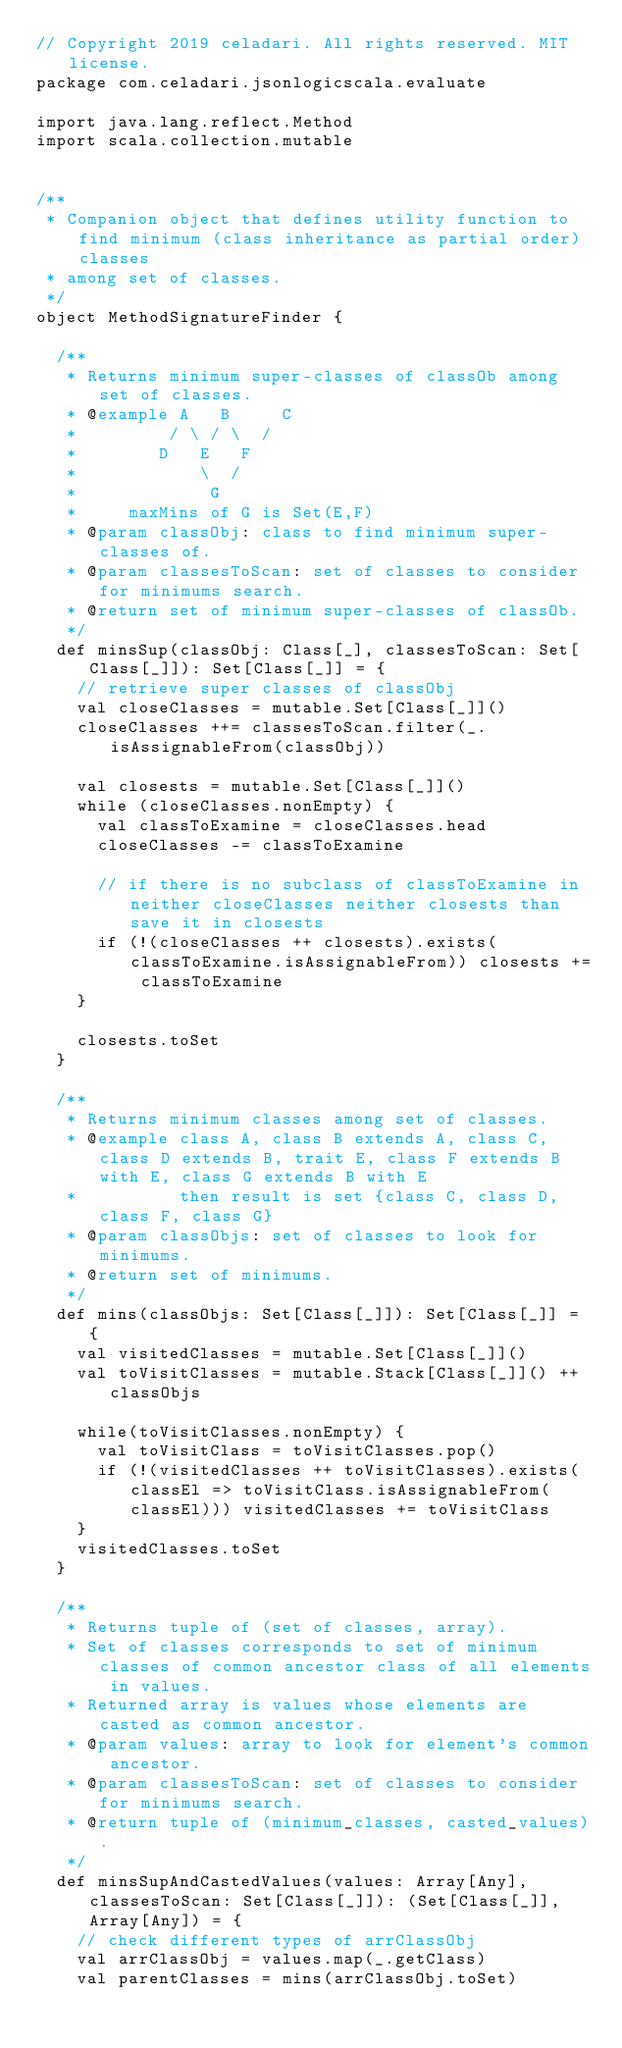<code> <loc_0><loc_0><loc_500><loc_500><_Scala_>// Copyright 2019 celadari. All rights reserved. MIT license.
package com.celadari.jsonlogicscala.evaluate

import java.lang.reflect.Method
import scala.collection.mutable


/**
 * Companion object that defines utility function to find minimum (class inheritance as partial order) classes
 * among set of classes.
 */
object MethodSignatureFinder {

  /**
   * Returns minimum super-classes of classOb among set of classes.
   * @example A   B     C
   *         / \ / \  /
   *        D   E   F
   *            \  /
   *             G
   *     maxMins of G is Set(E,F)
   * @param classObj: class to find minimum super-classes of.
   * @param classesToScan: set of classes to consider for minimums search.
   * @return set of minimum super-classes of classOb.
   */
  def minsSup(classObj: Class[_], classesToScan: Set[Class[_]]): Set[Class[_]] = {
    // retrieve super classes of classObj
    val closeClasses = mutable.Set[Class[_]]()
    closeClasses ++= classesToScan.filter(_.isAssignableFrom(classObj))

    val closests = mutable.Set[Class[_]]()
    while (closeClasses.nonEmpty) {
      val classToExamine = closeClasses.head
      closeClasses -= classToExamine

      // if there is no subclass of classToExamine in neither closeClasses neither closests than save it in closests
      if (!(closeClasses ++ closests).exists(classToExamine.isAssignableFrom)) closests += classToExamine
    }

    closests.toSet
  }

  /**
   * Returns minimum classes among set of classes.
   * @example class A, class B extends A, class C, class D extends B, trait E, class F extends B with E, class G extends B with E
   *          then result is set {class C, class D, class F, class G}
   * @param classObjs: set of classes to look for minimums.
   * @return set of minimums.
   */
  def mins(classObjs: Set[Class[_]]): Set[Class[_]] = {
    val visitedClasses = mutable.Set[Class[_]]()
    val toVisitClasses = mutable.Stack[Class[_]]() ++ classObjs

    while(toVisitClasses.nonEmpty) {
      val toVisitClass = toVisitClasses.pop()
      if (!(visitedClasses ++ toVisitClasses).exists(classEl => toVisitClass.isAssignableFrom(classEl))) visitedClasses += toVisitClass
    }
    visitedClasses.toSet
  }

  /**
   * Returns tuple of (set of classes, array).
   * Set of classes corresponds to set of minimum classes of common ancestor class of all elements in values.
   * Returned array is values whose elements are casted as common ancestor.
   * @param values: array to look for element's common ancestor.
   * @param classesToScan: set of classes to consider for minimums search.
   * @return tuple of (minimum_classes, casted_values).
   */
  def minsSupAndCastedValues(values: Array[Any], classesToScan: Set[Class[_]]): (Set[Class[_]], Array[Any]) = {
    // check different types of arrClassObj
    val arrClassObj = values.map(_.getClass)
    val parentClasses = mins(arrClassObj.toSet)</code> 